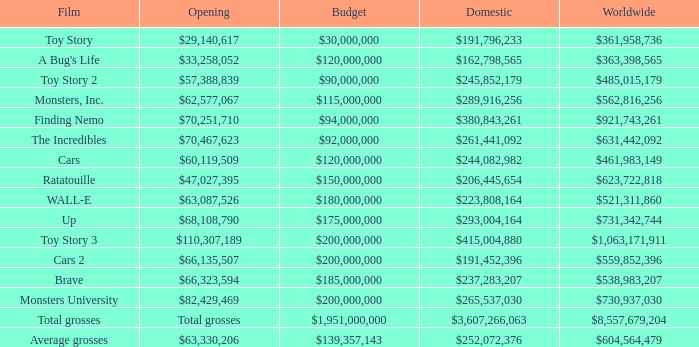WHAT IS THE OPENING WITH A WORLDWIDE NUMBER OF $559,852,396? $66,135,507. 